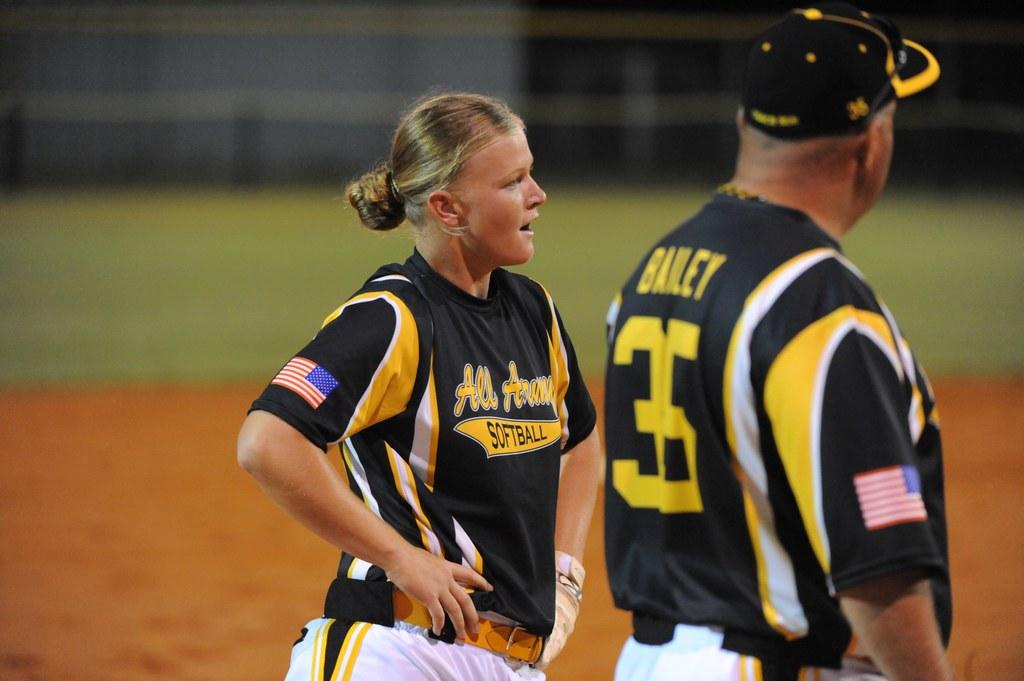<image>
Render a clear and concise summary of the photo. A softball player wearing an All Army jersey stands and talks to her coach. 